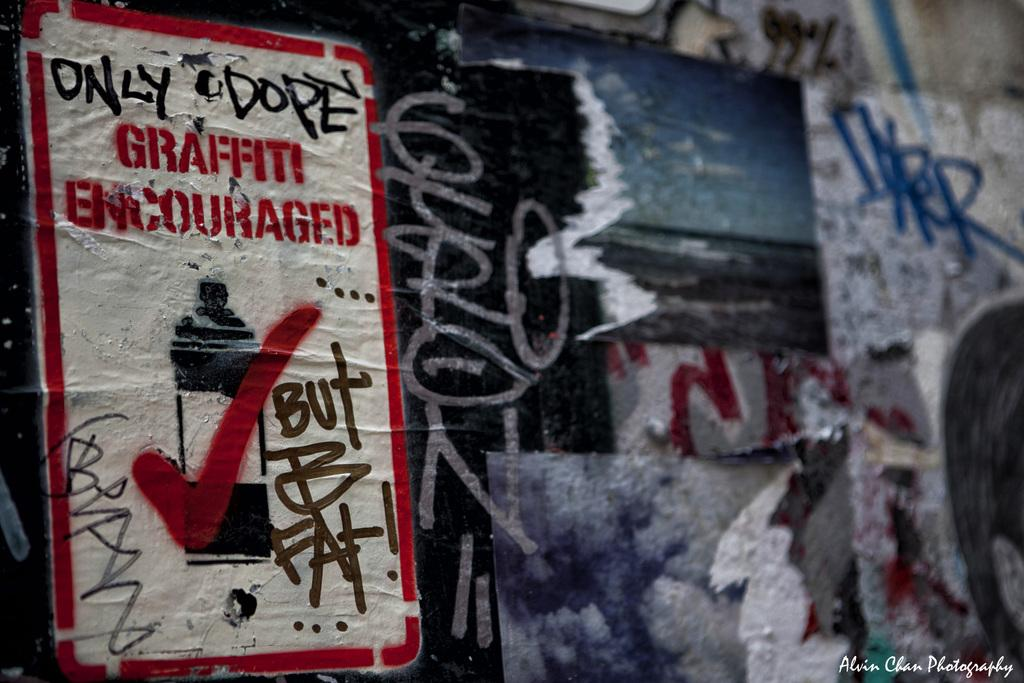<image>
Write a terse but informative summary of the picture. A bunch of graffiti covering a wall and a poster that says graffiti encouraged. 